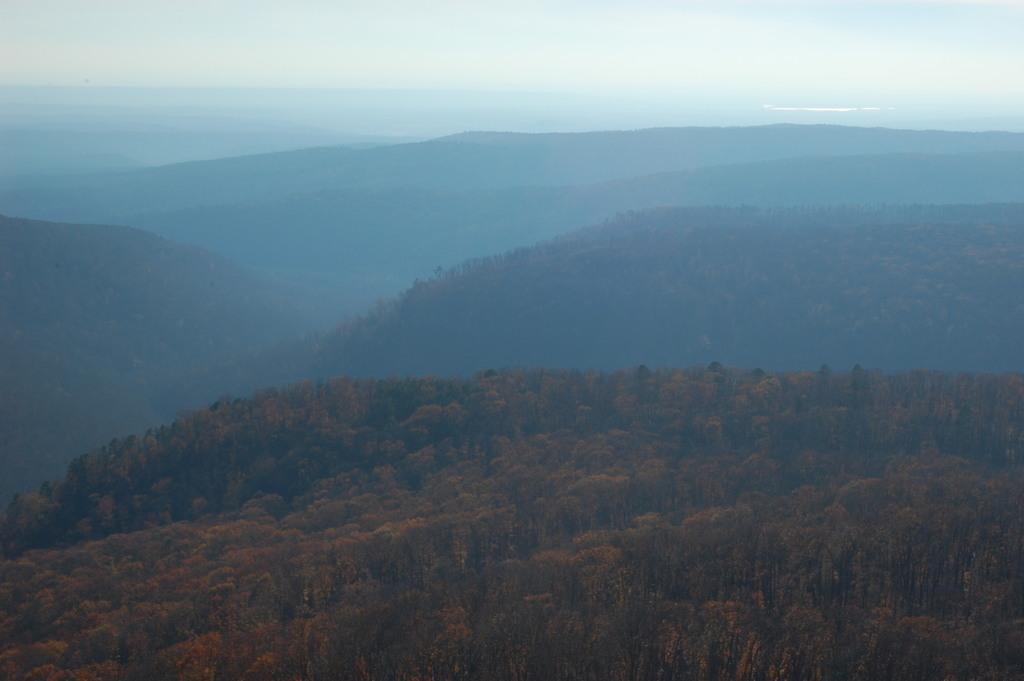How would you summarize this image in a sentence or two? This image is clicked near the mountains. In the front, there are mountains which are covered with plants and tree. To the top, there is sky. Beyond the mountains there is an ocean. 